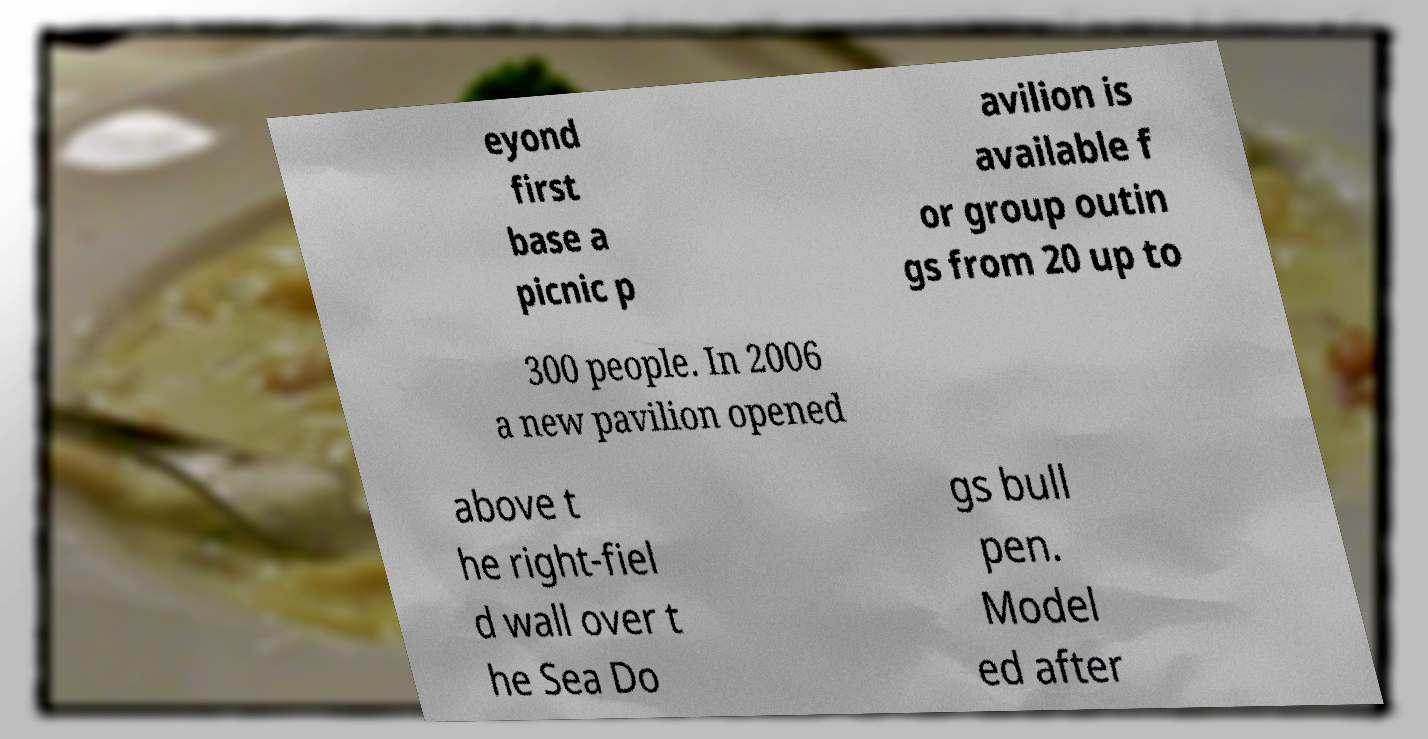There's text embedded in this image that I need extracted. Can you transcribe it verbatim? eyond first base a picnic p avilion is available f or group outin gs from 20 up to 300 people. In 2006 a new pavilion opened above t he right-fiel d wall over t he Sea Do gs bull pen. Model ed after 